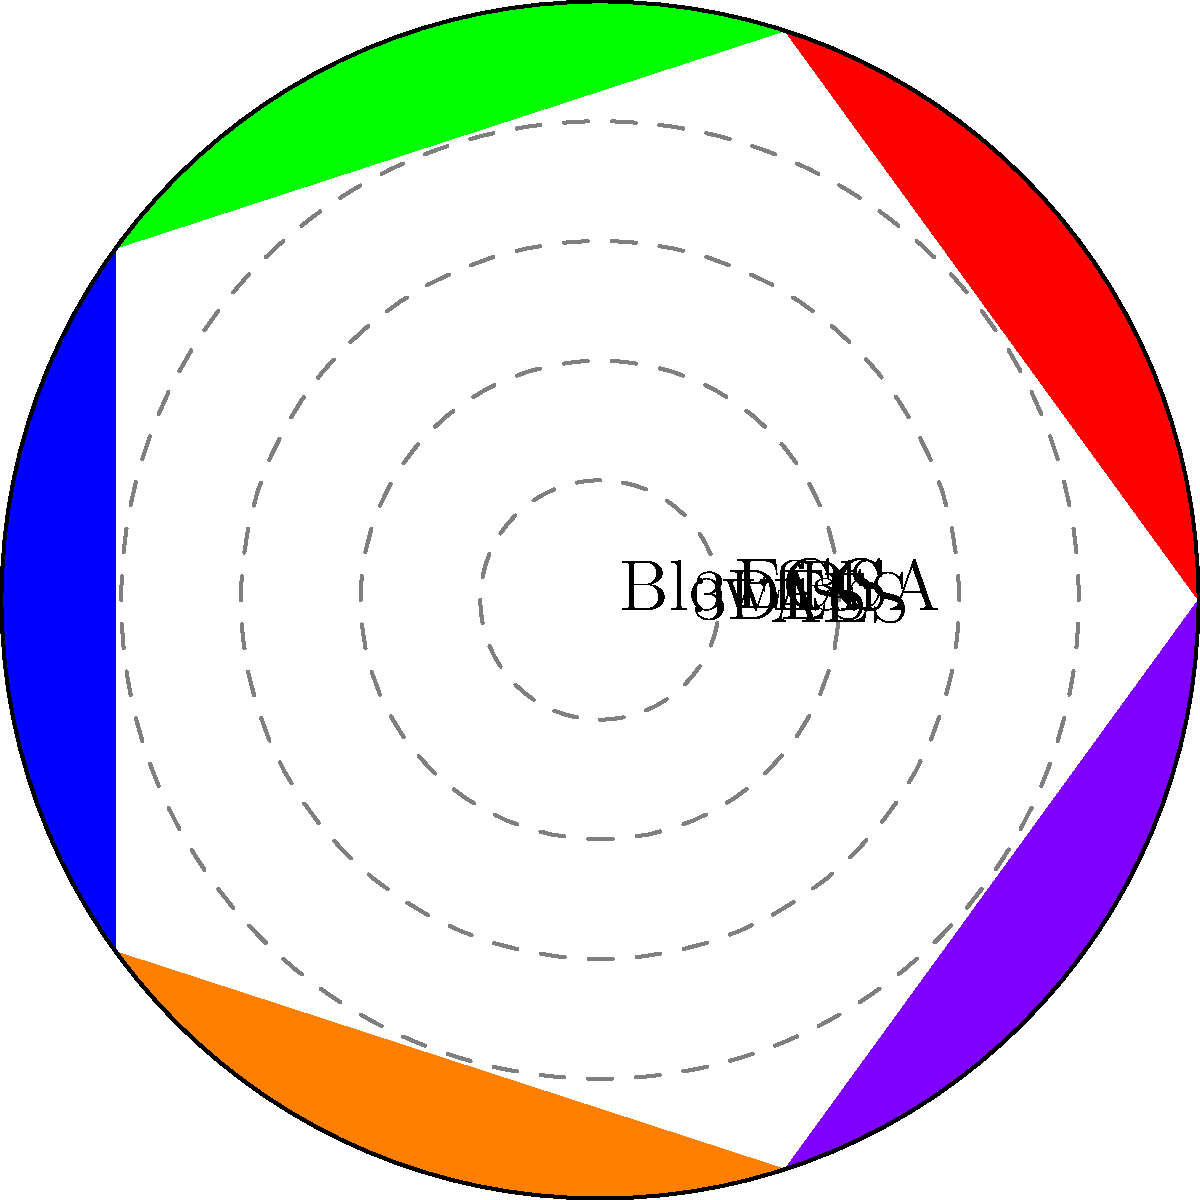In the polar area diagram above, which encryption algorithm is represented by the largest sector, indicating the highest relative strength? To determine which encryption algorithm has the highest relative strength, we need to compare the areas of each sector in the polar area diagram. The area of each sector is proportional to the strength of the corresponding algorithm.

Let's analyze each sector:

1. AES (red): Covers a large area, approximately 80% of the maximum radius.
2. 3DES (green): Covers a smaller area, about 60% of the maximum radius.
3. RSA (blue): Covers the largest area, approximately 90% of the maximum radius.
4. ECC (orange): Covers a moderately large area, about 70% of the maximum radius.
5. Blowfish (purple): Covers the smallest area, approximately 50% of the maximum radius.

By visually comparing these sectors, we can see that the blue sector, representing RSA, has the largest area and thus indicates the highest relative strength among the given encryption algorithms.

It's important to note that this diagram represents relative strengths and may not reflect the absolute security of these algorithms in all contexts. Factors such as key size, implementation, and specific use cases can affect the actual security of an encryption algorithm.
Answer: RSA 